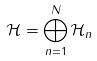<formula> <loc_0><loc_0><loc_500><loc_500>\mathcal { H } = \bigoplus _ { n = 1 } ^ { N } \mathcal { H } _ { n }</formula> 